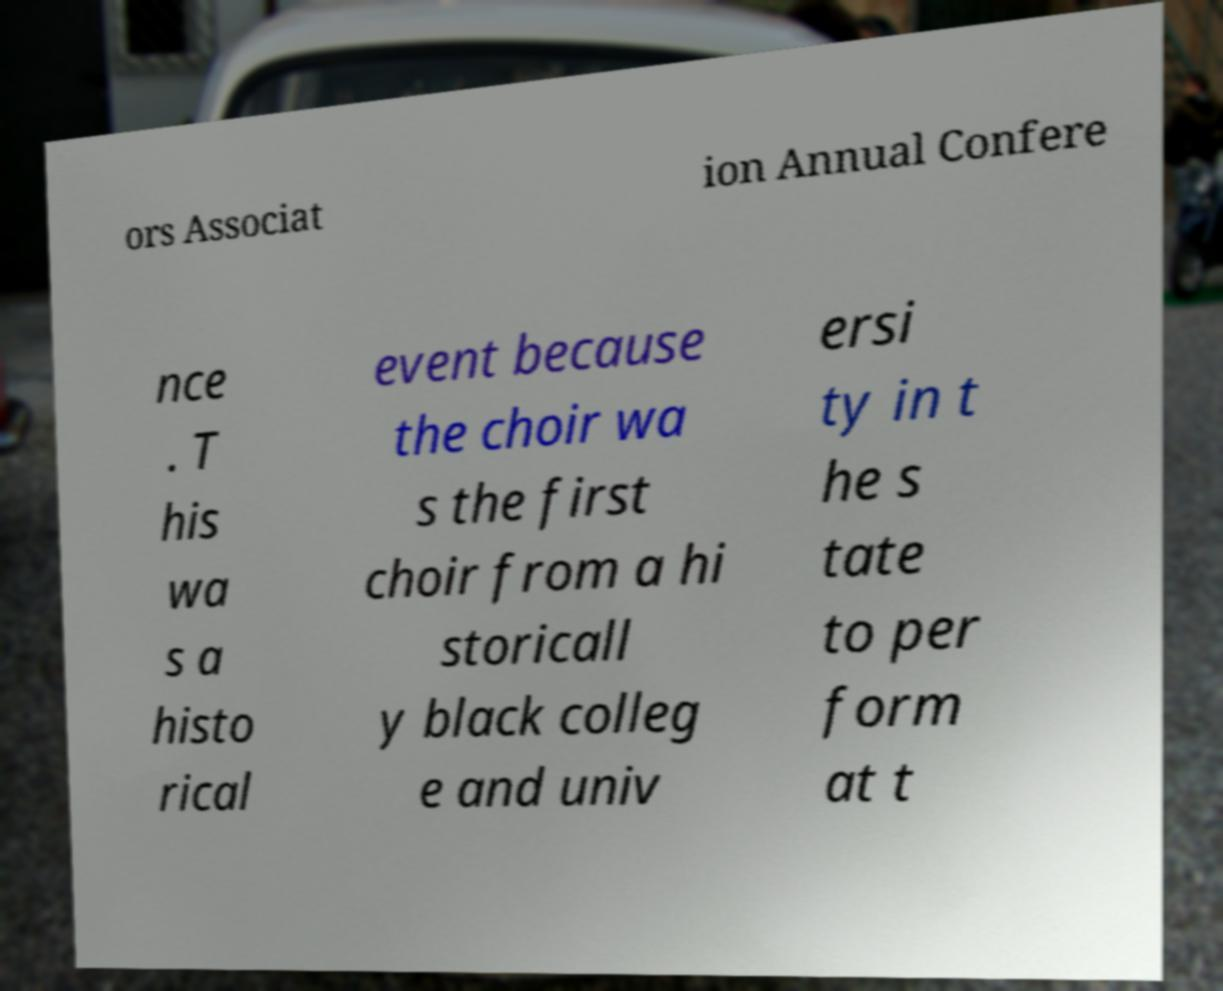Could you extract and type out the text from this image? ors Associat ion Annual Confere nce . T his wa s a histo rical event because the choir wa s the first choir from a hi storicall y black colleg e and univ ersi ty in t he s tate to per form at t 